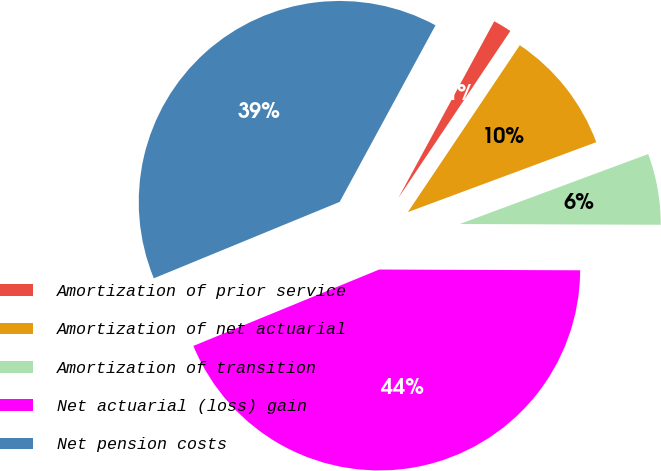<chart> <loc_0><loc_0><loc_500><loc_500><pie_chart><fcel>Amortization of prior service<fcel>Amortization of net actuarial<fcel>Amortization of transition<fcel>Net actuarial (loss) gain<fcel>Net pension costs<nl><fcel>1.49%<fcel>9.94%<fcel>5.72%<fcel>43.73%<fcel>39.12%<nl></chart> 